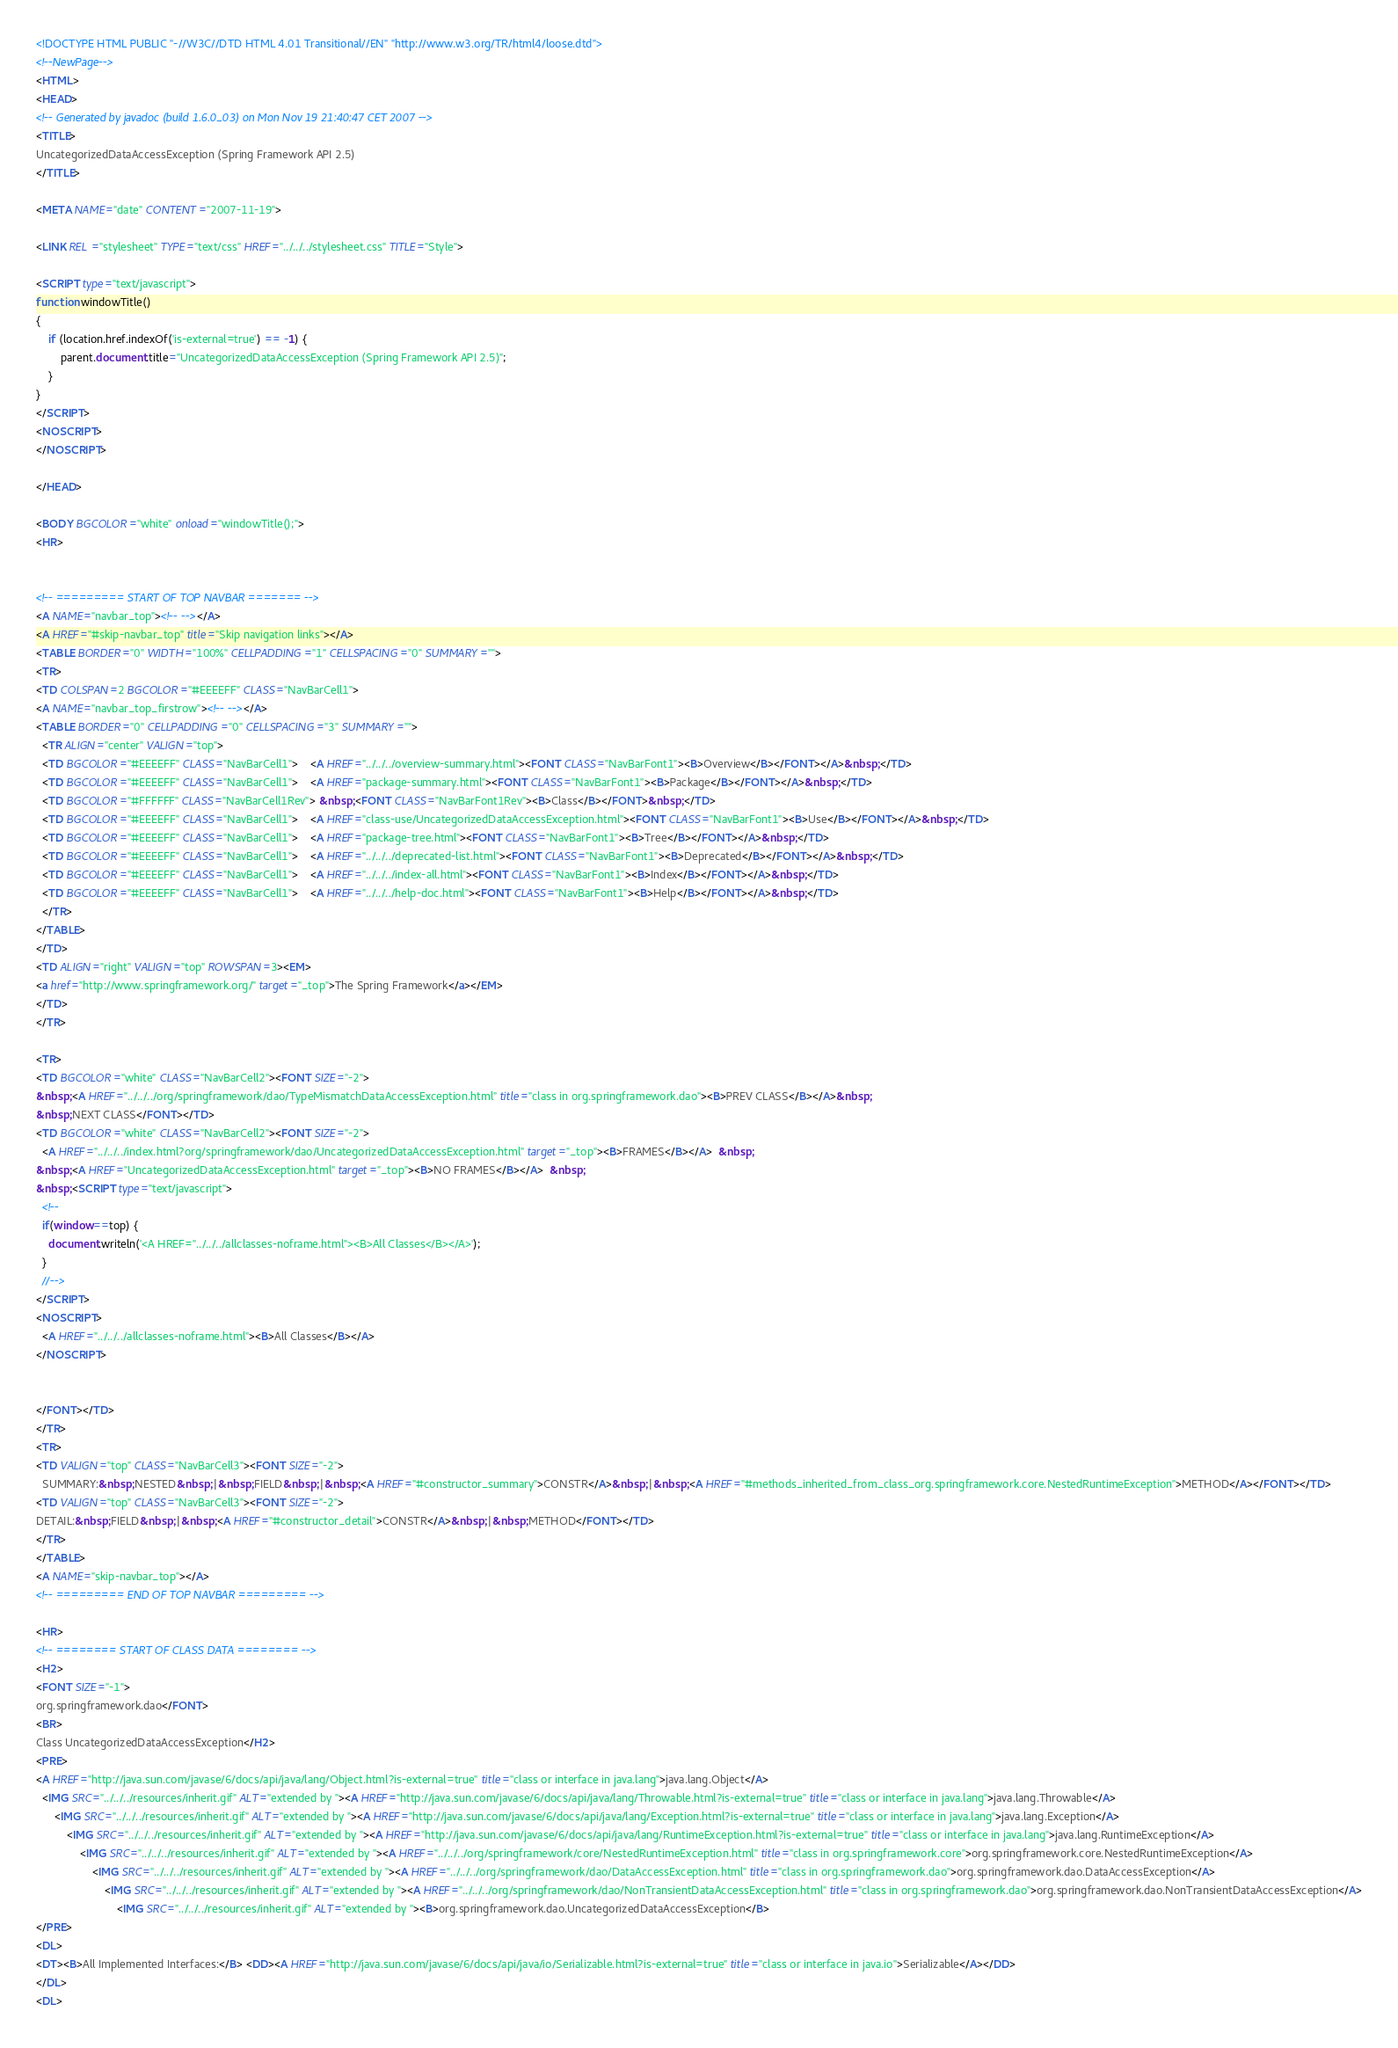<code> <loc_0><loc_0><loc_500><loc_500><_HTML_><!DOCTYPE HTML PUBLIC "-//W3C//DTD HTML 4.01 Transitional//EN" "http://www.w3.org/TR/html4/loose.dtd">
<!--NewPage-->
<HTML>
<HEAD>
<!-- Generated by javadoc (build 1.6.0_03) on Mon Nov 19 21:40:47 CET 2007 -->
<TITLE>
UncategorizedDataAccessException (Spring Framework API 2.5)
</TITLE>

<META NAME="date" CONTENT="2007-11-19">

<LINK REL ="stylesheet" TYPE="text/css" HREF="../../../stylesheet.css" TITLE="Style">

<SCRIPT type="text/javascript">
function windowTitle()
{
    if (location.href.indexOf('is-external=true') == -1) {
        parent.document.title="UncategorizedDataAccessException (Spring Framework API 2.5)";
    }
}
</SCRIPT>
<NOSCRIPT>
</NOSCRIPT>

</HEAD>

<BODY BGCOLOR="white" onload="windowTitle();">
<HR>


<!-- ========= START OF TOP NAVBAR ======= -->
<A NAME="navbar_top"><!-- --></A>
<A HREF="#skip-navbar_top" title="Skip navigation links"></A>
<TABLE BORDER="0" WIDTH="100%" CELLPADDING="1" CELLSPACING="0" SUMMARY="">
<TR>
<TD COLSPAN=2 BGCOLOR="#EEEEFF" CLASS="NavBarCell1">
<A NAME="navbar_top_firstrow"><!-- --></A>
<TABLE BORDER="0" CELLPADDING="0" CELLSPACING="3" SUMMARY="">
  <TR ALIGN="center" VALIGN="top">
  <TD BGCOLOR="#EEEEFF" CLASS="NavBarCell1">    <A HREF="../../../overview-summary.html"><FONT CLASS="NavBarFont1"><B>Overview</B></FONT></A>&nbsp;</TD>
  <TD BGCOLOR="#EEEEFF" CLASS="NavBarCell1">    <A HREF="package-summary.html"><FONT CLASS="NavBarFont1"><B>Package</B></FONT></A>&nbsp;</TD>
  <TD BGCOLOR="#FFFFFF" CLASS="NavBarCell1Rev"> &nbsp;<FONT CLASS="NavBarFont1Rev"><B>Class</B></FONT>&nbsp;</TD>
  <TD BGCOLOR="#EEEEFF" CLASS="NavBarCell1">    <A HREF="class-use/UncategorizedDataAccessException.html"><FONT CLASS="NavBarFont1"><B>Use</B></FONT></A>&nbsp;</TD>
  <TD BGCOLOR="#EEEEFF" CLASS="NavBarCell1">    <A HREF="package-tree.html"><FONT CLASS="NavBarFont1"><B>Tree</B></FONT></A>&nbsp;</TD>
  <TD BGCOLOR="#EEEEFF" CLASS="NavBarCell1">    <A HREF="../../../deprecated-list.html"><FONT CLASS="NavBarFont1"><B>Deprecated</B></FONT></A>&nbsp;</TD>
  <TD BGCOLOR="#EEEEFF" CLASS="NavBarCell1">    <A HREF="../../../index-all.html"><FONT CLASS="NavBarFont1"><B>Index</B></FONT></A>&nbsp;</TD>
  <TD BGCOLOR="#EEEEFF" CLASS="NavBarCell1">    <A HREF="../../../help-doc.html"><FONT CLASS="NavBarFont1"><B>Help</B></FONT></A>&nbsp;</TD>
  </TR>
</TABLE>
</TD>
<TD ALIGN="right" VALIGN="top" ROWSPAN=3><EM>
<a href="http://www.springframework.org/" target="_top">The Spring Framework</a></EM>
</TD>
</TR>

<TR>
<TD BGCOLOR="white" CLASS="NavBarCell2"><FONT SIZE="-2">
&nbsp;<A HREF="../../../org/springframework/dao/TypeMismatchDataAccessException.html" title="class in org.springframework.dao"><B>PREV CLASS</B></A>&nbsp;
&nbsp;NEXT CLASS</FONT></TD>
<TD BGCOLOR="white" CLASS="NavBarCell2"><FONT SIZE="-2">
  <A HREF="../../../index.html?org/springframework/dao/UncategorizedDataAccessException.html" target="_top"><B>FRAMES</B></A>  &nbsp;
&nbsp;<A HREF="UncategorizedDataAccessException.html" target="_top"><B>NO FRAMES</B></A>  &nbsp;
&nbsp;<SCRIPT type="text/javascript">
  <!--
  if(window==top) {
    document.writeln('<A HREF="../../../allclasses-noframe.html"><B>All Classes</B></A>');
  }
  //-->
</SCRIPT>
<NOSCRIPT>
  <A HREF="../../../allclasses-noframe.html"><B>All Classes</B></A>
</NOSCRIPT>


</FONT></TD>
</TR>
<TR>
<TD VALIGN="top" CLASS="NavBarCell3"><FONT SIZE="-2">
  SUMMARY:&nbsp;NESTED&nbsp;|&nbsp;FIELD&nbsp;|&nbsp;<A HREF="#constructor_summary">CONSTR</A>&nbsp;|&nbsp;<A HREF="#methods_inherited_from_class_org.springframework.core.NestedRuntimeException">METHOD</A></FONT></TD>
<TD VALIGN="top" CLASS="NavBarCell3"><FONT SIZE="-2">
DETAIL:&nbsp;FIELD&nbsp;|&nbsp;<A HREF="#constructor_detail">CONSTR</A>&nbsp;|&nbsp;METHOD</FONT></TD>
</TR>
</TABLE>
<A NAME="skip-navbar_top"></A>
<!-- ========= END OF TOP NAVBAR ========= -->

<HR>
<!-- ======== START OF CLASS DATA ======== -->
<H2>
<FONT SIZE="-1">
org.springframework.dao</FONT>
<BR>
Class UncategorizedDataAccessException</H2>
<PRE>
<A HREF="http://java.sun.com/javase/6/docs/api/java/lang/Object.html?is-external=true" title="class or interface in java.lang">java.lang.Object</A>
  <IMG SRC="../../../resources/inherit.gif" ALT="extended by "><A HREF="http://java.sun.com/javase/6/docs/api/java/lang/Throwable.html?is-external=true" title="class or interface in java.lang">java.lang.Throwable</A>
      <IMG SRC="../../../resources/inherit.gif" ALT="extended by "><A HREF="http://java.sun.com/javase/6/docs/api/java/lang/Exception.html?is-external=true" title="class or interface in java.lang">java.lang.Exception</A>
          <IMG SRC="../../../resources/inherit.gif" ALT="extended by "><A HREF="http://java.sun.com/javase/6/docs/api/java/lang/RuntimeException.html?is-external=true" title="class or interface in java.lang">java.lang.RuntimeException</A>
              <IMG SRC="../../../resources/inherit.gif" ALT="extended by "><A HREF="../../../org/springframework/core/NestedRuntimeException.html" title="class in org.springframework.core">org.springframework.core.NestedRuntimeException</A>
                  <IMG SRC="../../../resources/inherit.gif" ALT="extended by "><A HREF="../../../org/springframework/dao/DataAccessException.html" title="class in org.springframework.dao">org.springframework.dao.DataAccessException</A>
                      <IMG SRC="../../../resources/inherit.gif" ALT="extended by "><A HREF="../../../org/springframework/dao/NonTransientDataAccessException.html" title="class in org.springframework.dao">org.springframework.dao.NonTransientDataAccessException</A>
                          <IMG SRC="../../../resources/inherit.gif" ALT="extended by "><B>org.springframework.dao.UncategorizedDataAccessException</B>
</PRE>
<DL>
<DT><B>All Implemented Interfaces:</B> <DD><A HREF="http://java.sun.com/javase/6/docs/api/java/io/Serializable.html?is-external=true" title="class or interface in java.io">Serializable</A></DD>
</DL>
<DL></code> 